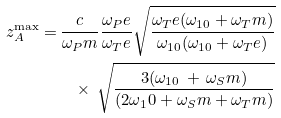<formula> <loc_0><loc_0><loc_500><loc_500>z _ { A } ^ { \max } = & \, \frac { c } { \omega _ { P } m } \frac { \omega _ { P } e } { \omega _ { T } e } \sqrt { \frac { \omega _ { T } e ( \omega _ { 1 0 } + \omega _ { T } m ) } { \omega _ { 1 0 } ( \omega _ { 1 0 } + \omega _ { T } e ) } } \\ & \quad \times \, \sqrt { \frac { 3 ( \omega _ { 1 0 } \, + \, \omega _ { S } m ) } { ( 2 \omega _ { 1 } 0 + \omega _ { S } m + \omega _ { T } m ) } }</formula> 